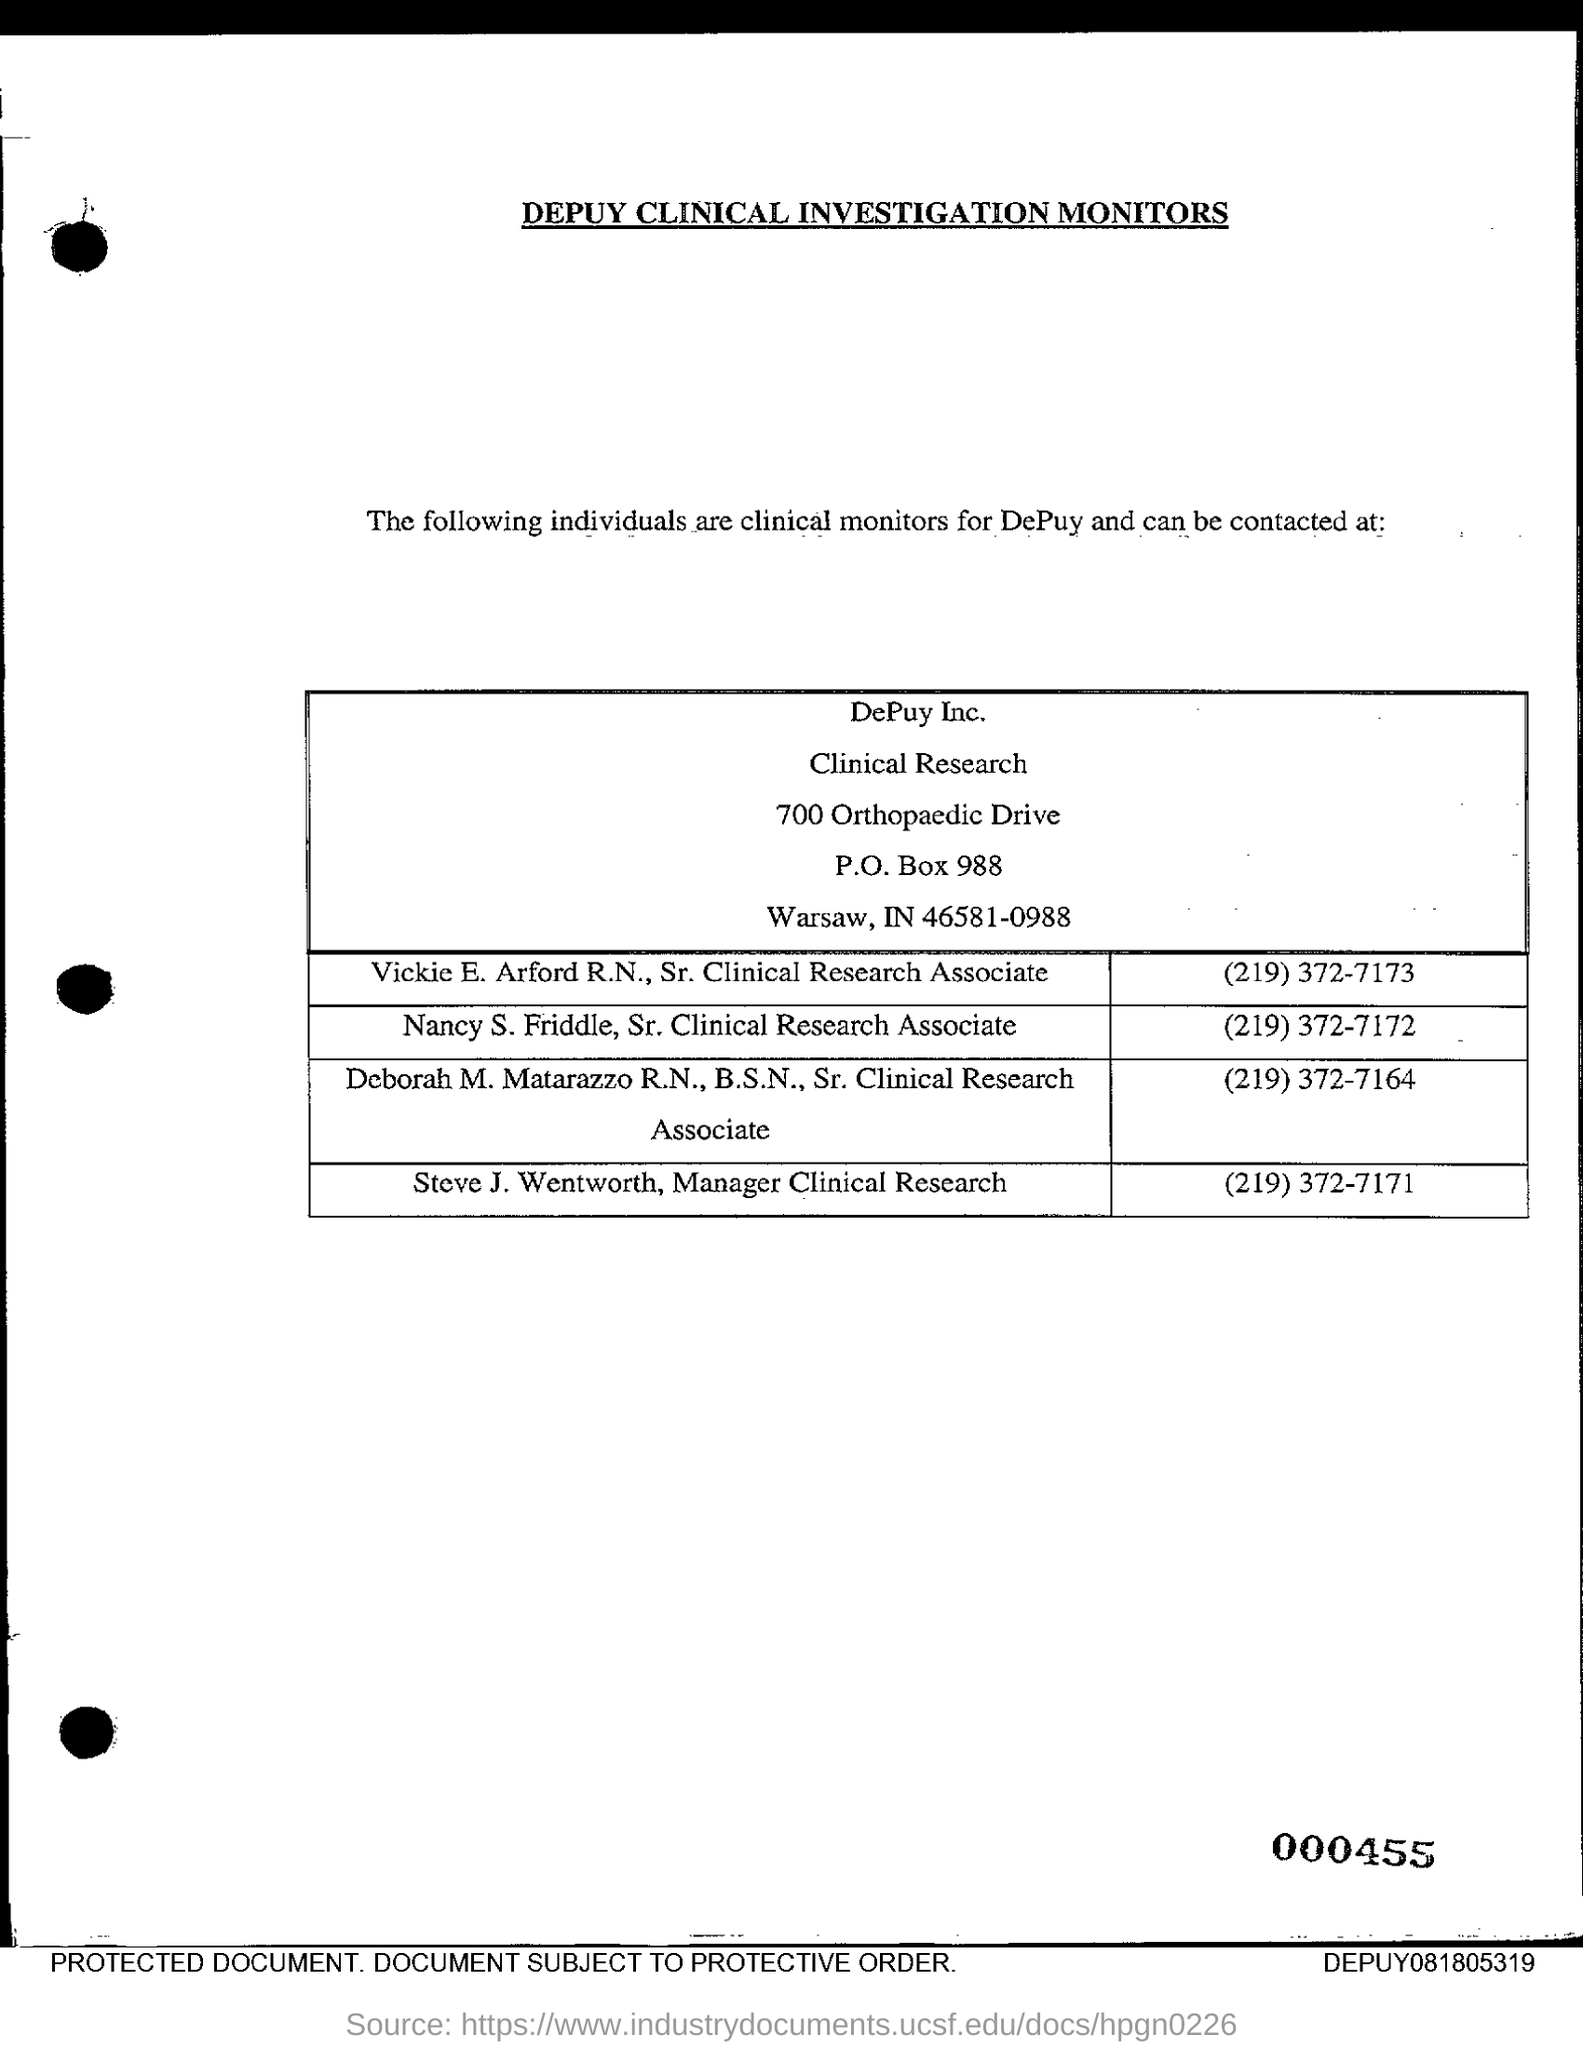What is the title of this document given in capital letters?
Your response must be concise. DEPUY CLINICAL INVESTIGATION MONITORS. What is the P.O. Box number given?
Your answer should be compact. 988. What is the Zip code given in this document?
Your response must be concise. 46581. What is the number of Vickie E. Arford R.N to be contacted at?
Offer a very short reply. (219) 372-7173. What is the company name?
Offer a terse response. DePuy Inc. What is the designation of Vickie E. Arford R.N.?
Provide a short and direct response. Sr. Clinical Research Associate. What is the name of Manager Clinical Research?
Your answer should be compact. Steve J. Wentworth. What is the number of Deborah M. Matarazzo R.N.,B.S.N. to be contacted at?.
Offer a very short reply. (219) 372-7164. What is the number of manager clinical research to be contacted at?
Offer a very short reply. (219) 372-7171. What is the designation of Nancy S. Friddle?
Keep it short and to the point. Sr. Clinical Research  Associate. 